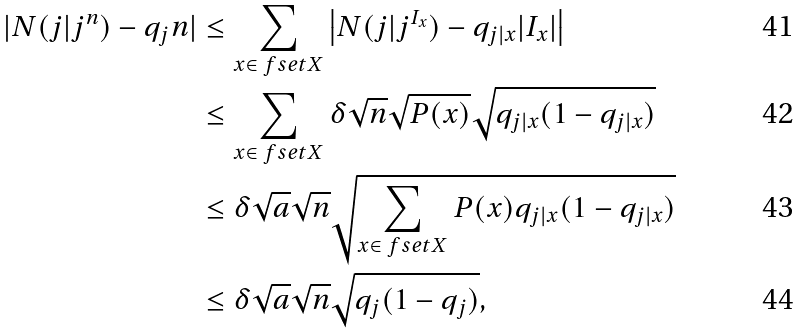<formula> <loc_0><loc_0><loc_500><loc_500>| N ( j | j ^ { n } ) - q _ { j } n | & \leq \sum _ { x \in \ f s e t { X } } \left | N ( j | j ^ { I _ { x } } ) - q _ { j | x } | I _ { x } | \right | \\ & \leq \sum _ { x \in \ f s e t { X } } \delta \sqrt { n } \sqrt { P ( x ) } \sqrt { q _ { j | x } ( 1 - q _ { j | x } ) } \\ & \leq \delta \sqrt { a } \sqrt { n } \sqrt { \sum _ { x \in \ f s e t { X } } P ( x ) q _ { j | x } ( 1 - q _ { j | x } ) } \\ & \leq \delta \sqrt { a } \sqrt { n } \sqrt { q _ { j } ( 1 - q _ { j } ) } ,</formula> 